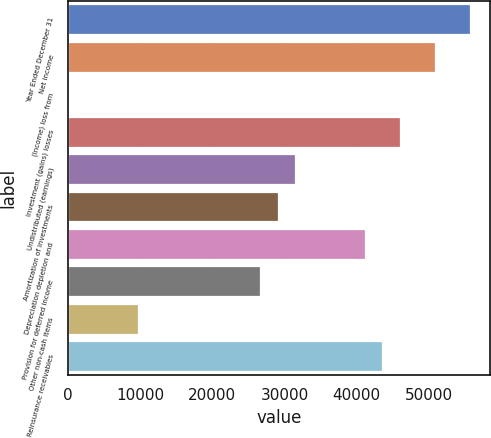<chart> <loc_0><loc_0><loc_500><loc_500><bar_chart><fcel>Year Ended December 31<fcel>Net income<fcel>(Income) loss from<fcel>Investment (gains) losses<fcel>Undistributed (earnings)<fcel>Amortization of investments<fcel>Depreciation depletion and<fcel>Provision for deferred income<fcel>Other non-cash items<fcel>Reinsurance receivables<nl><fcel>55632.1<fcel>50794.7<fcel>2<fcel>45957.3<fcel>31445.1<fcel>29026.4<fcel>41119.9<fcel>26607.7<fcel>9676.8<fcel>43538.6<nl></chart> 